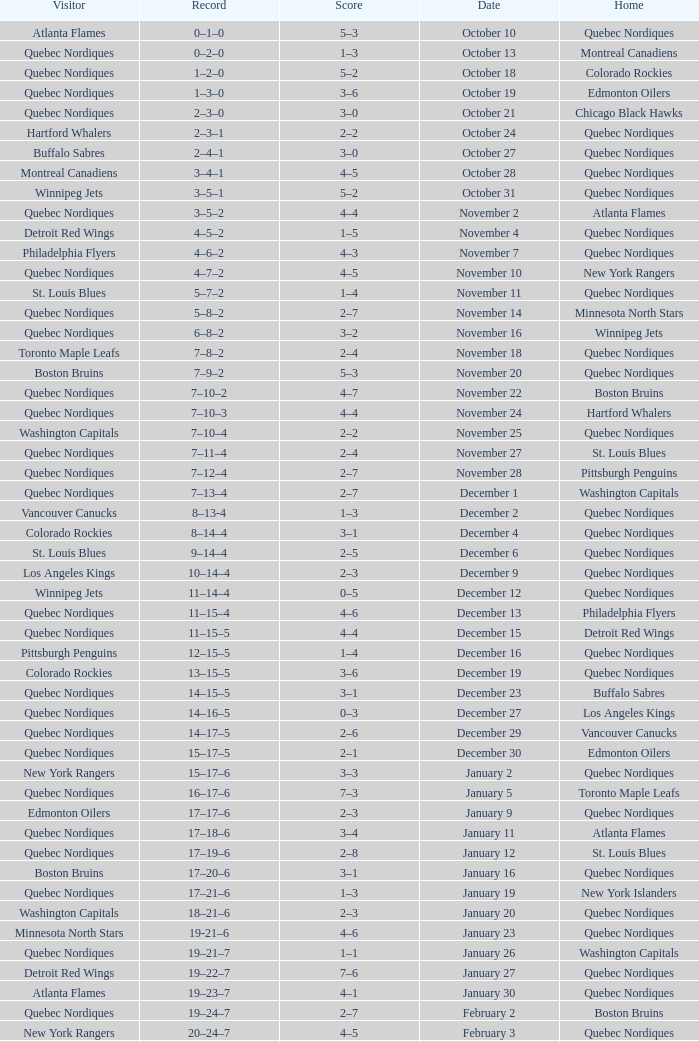Which Date has a Score of 2–7, and a Record of 5–8–2? November 14. 